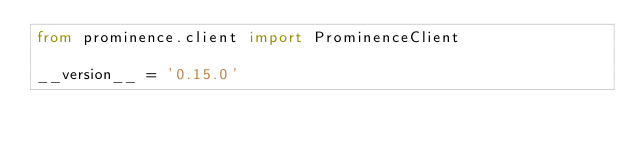<code> <loc_0><loc_0><loc_500><loc_500><_Python_>from prominence.client import ProminenceClient

__version__ = '0.15.0'
</code> 